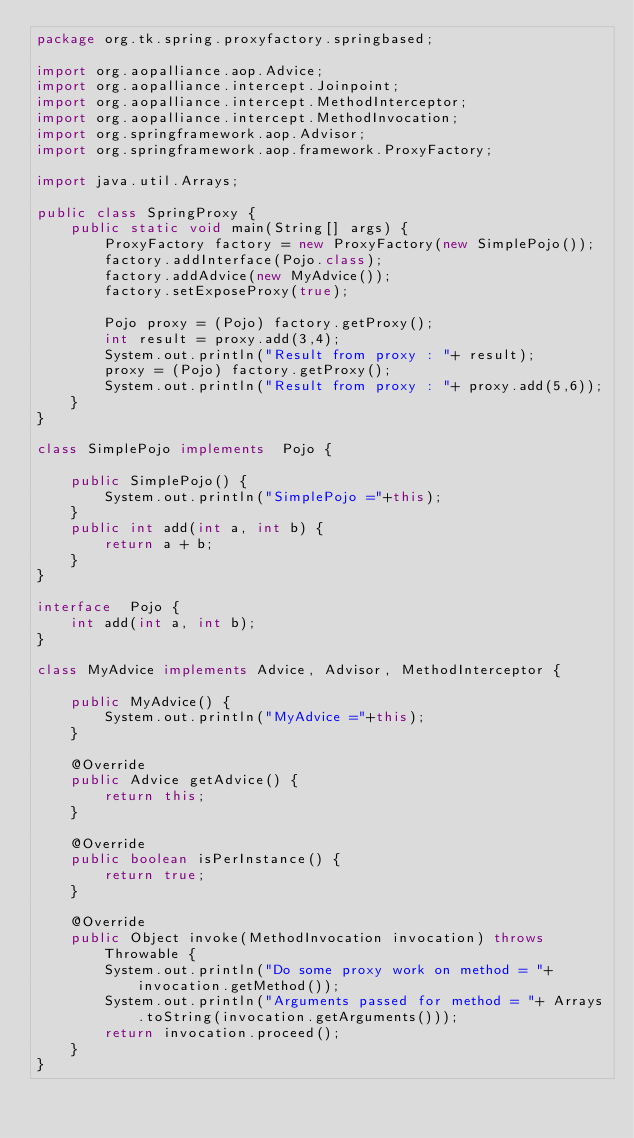Convert code to text. <code><loc_0><loc_0><loc_500><loc_500><_Java_>package org.tk.spring.proxyfactory.springbased;

import org.aopalliance.aop.Advice;
import org.aopalliance.intercept.Joinpoint;
import org.aopalliance.intercept.MethodInterceptor;
import org.aopalliance.intercept.MethodInvocation;
import org.springframework.aop.Advisor;
import org.springframework.aop.framework.ProxyFactory;

import java.util.Arrays;

public class SpringProxy {
    public static void main(String[] args) {
        ProxyFactory factory = new ProxyFactory(new SimplePojo());
        factory.addInterface(Pojo.class);
        factory.addAdvice(new MyAdvice());
        factory.setExposeProxy(true);

        Pojo proxy = (Pojo) factory.getProxy();
        int result = proxy.add(3,4);
        System.out.println("Result from proxy : "+ result);
        proxy = (Pojo) factory.getProxy();
        System.out.println("Result from proxy : "+ proxy.add(5,6));
    }
}

class SimplePojo implements  Pojo {

    public SimplePojo() {
        System.out.println("SimplePojo ="+this);
    }
    public int add(int a, int b) {
        return a + b;
    }
}

interface  Pojo {
    int add(int a, int b);
}

class MyAdvice implements Advice, Advisor, MethodInterceptor {

    public MyAdvice() {
        System.out.println("MyAdvice ="+this);
    }

    @Override
    public Advice getAdvice() {
        return this;
    }

    @Override
    public boolean isPerInstance() {
        return true;
    }

    @Override
    public Object invoke(MethodInvocation invocation) throws Throwable {
        System.out.println("Do some proxy work on method = "+ invocation.getMethod());
        System.out.println("Arguments passed for method = "+ Arrays.toString(invocation.getArguments()));
        return invocation.proceed();
    }
}</code> 